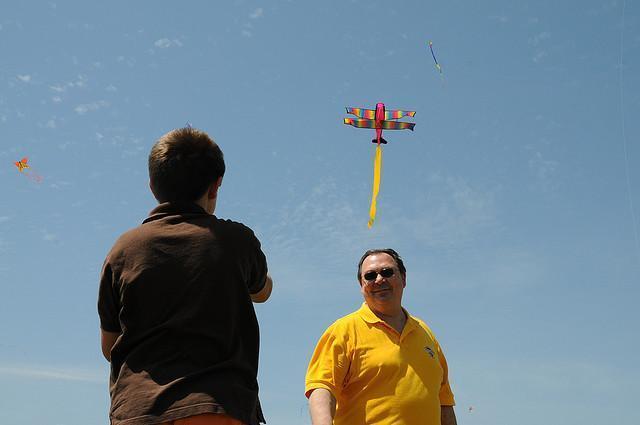How many people can be seen?
Give a very brief answer. 2. How many people have a umbrella in the picture?
Give a very brief answer. 0. 